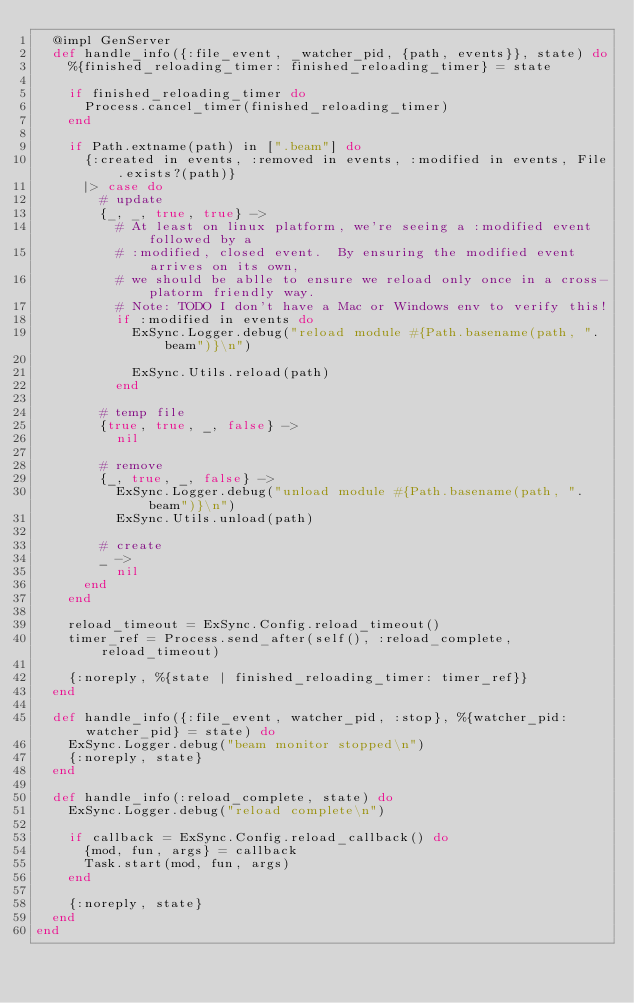<code> <loc_0><loc_0><loc_500><loc_500><_Elixir_>  @impl GenServer
  def handle_info({:file_event, _watcher_pid, {path, events}}, state) do
    %{finished_reloading_timer: finished_reloading_timer} = state

    if finished_reloading_timer do
      Process.cancel_timer(finished_reloading_timer)
    end

    if Path.extname(path) in [".beam"] do
      {:created in events, :removed in events, :modified in events, File.exists?(path)}
      |> case do
        # update
        {_, _, true, true} ->
          # At least on linux platform, we're seeing a :modified event followed by a
          # :modified, closed event.  By ensuring the modified event arrives on its own,
          # we should be ablle to ensure we reload only once in a cross-platorm friendly way.
          # Note: TODO I don't have a Mac or Windows env to verify this!
          if :modified in events do
            ExSync.Logger.debug("reload module #{Path.basename(path, ".beam")}\n")

            ExSync.Utils.reload(path)
          end

        # temp file
        {true, true, _, false} ->
          nil

        # remove
        {_, true, _, false} ->
          ExSync.Logger.debug("unload module #{Path.basename(path, ".beam")}\n")
          ExSync.Utils.unload(path)

        # create
        _ ->
          nil
      end
    end

    reload_timeout = ExSync.Config.reload_timeout()
    timer_ref = Process.send_after(self(), :reload_complete, reload_timeout)

    {:noreply, %{state | finished_reloading_timer: timer_ref}}
  end

  def handle_info({:file_event, watcher_pid, :stop}, %{watcher_pid: watcher_pid} = state) do
    ExSync.Logger.debug("beam monitor stopped\n")
    {:noreply, state}
  end

  def handle_info(:reload_complete, state) do
    ExSync.Logger.debug("reload complete\n")

    if callback = ExSync.Config.reload_callback() do
      {mod, fun, args} = callback
      Task.start(mod, fun, args)
    end

    {:noreply, state}
  end
end
</code> 